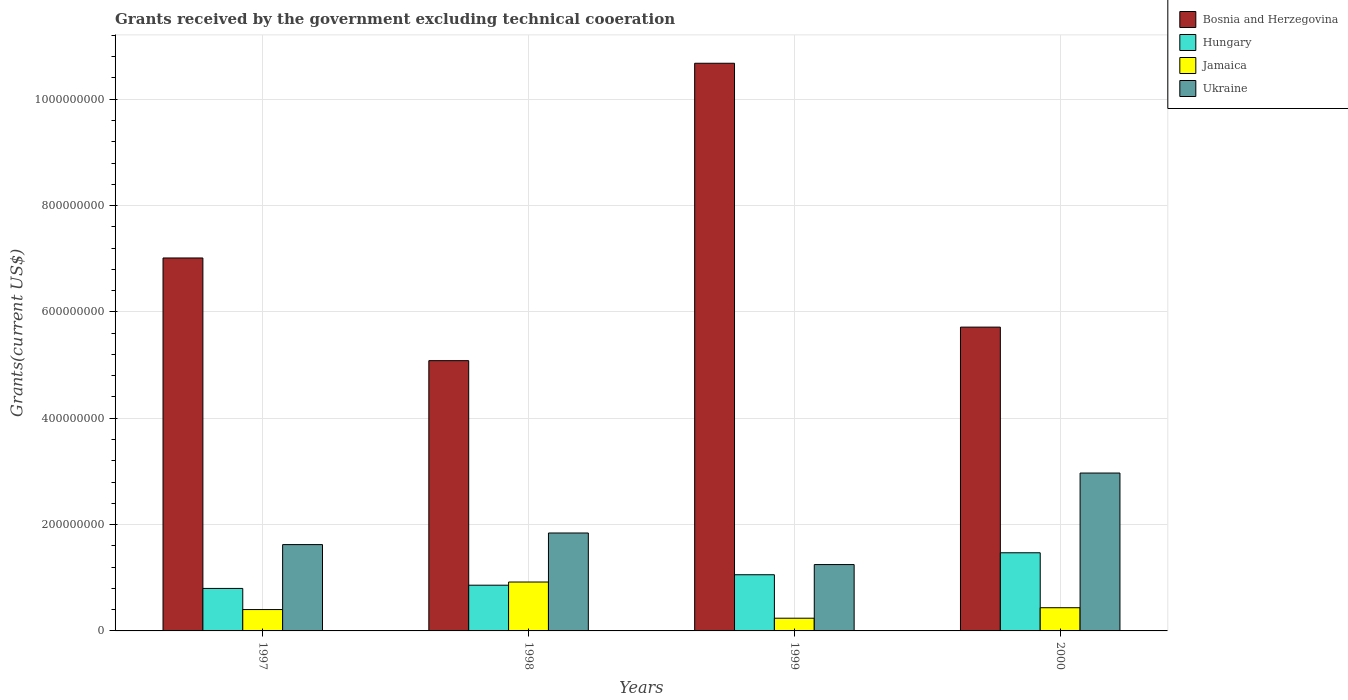How many groups of bars are there?
Your response must be concise. 4. How many bars are there on the 1st tick from the right?
Provide a short and direct response. 4. What is the label of the 2nd group of bars from the left?
Give a very brief answer. 1998. What is the total grants received by the government in Bosnia and Herzegovina in 1999?
Your response must be concise. 1.07e+09. Across all years, what is the maximum total grants received by the government in Jamaica?
Your answer should be very brief. 9.20e+07. Across all years, what is the minimum total grants received by the government in Hungary?
Your answer should be very brief. 7.99e+07. In which year was the total grants received by the government in Bosnia and Herzegovina maximum?
Your answer should be very brief. 1999. What is the total total grants received by the government in Ukraine in the graph?
Your response must be concise. 7.68e+08. What is the difference between the total grants received by the government in Jamaica in 1997 and that in 1999?
Keep it short and to the point. 1.63e+07. What is the difference between the total grants received by the government in Ukraine in 1997 and the total grants received by the government in Jamaica in 1999?
Give a very brief answer. 1.38e+08. What is the average total grants received by the government in Jamaica per year?
Ensure brevity in your answer.  4.99e+07. In the year 1998, what is the difference between the total grants received by the government in Hungary and total grants received by the government in Jamaica?
Your response must be concise. -5.97e+06. In how many years, is the total grants received by the government in Jamaica greater than 360000000 US$?
Offer a very short reply. 0. What is the ratio of the total grants received by the government in Hungary in 1997 to that in 1999?
Make the answer very short. 0.76. Is the total grants received by the government in Bosnia and Herzegovina in 1998 less than that in 1999?
Your answer should be very brief. Yes. What is the difference between the highest and the second highest total grants received by the government in Hungary?
Keep it short and to the point. 4.13e+07. What is the difference between the highest and the lowest total grants received by the government in Ukraine?
Your answer should be very brief. 1.72e+08. Is the sum of the total grants received by the government in Ukraine in 1998 and 1999 greater than the maximum total grants received by the government in Bosnia and Herzegovina across all years?
Ensure brevity in your answer.  No. What does the 2nd bar from the left in 1999 represents?
Give a very brief answer. Hungary. What does the 4th bar from the right in 2000 represents?
Your answer should be compact. Bosnia and Herzegovina. Is it the case that in every year, the sum of the total grants received by the government in Ukraine and total grants received by the government in Jamaica is greater than the total grants received by the government in Bosnia and Herzegovina?
Provide a succinct answer. No. Are all the bars in the graph horizontal?
Ensure brevity in your answer.  No. What is the difference between two consecutive major ticks on the Y-axis?
Provide a short and direct response. 2.00e+08. Where does the legend appear in the graph?
Keep it short and to the point. Top right. How many legend labels are there?
Provide a succinct answer. 4. How are the legend labels stacked?
Your answer should be very brief. Vertical. What is the title of the graph?
Your response must be concise. Grants received by the government excluding technical cooeration. What is the label or title of the Y-axis?
Offer a very short reply. Grants(current US$). What is the Grants(current US$) of Bosnia and Herzegovina in 1997?
Your answer should be compact. 7.01e+08. What is the Grants(current US$) of Hungary in 1997?
Your answer should be compact. 7.99e+07. What is the Grants(current US$) in Jamaica in 1997?
Provide a short and direct response. 4.02e+07. What is the Grants(current US$) of Ukraine in 1997?
Make the answer very short. 1.62e+08. What is the Grants(current US$) in Bosnia and Herzegovina in 1998?
Ensure brevity in your answer.  5.08e+08. What is the Grants(current US$) of Hungary in 1998?
Provide a short and direct response. 8.60e+07. What is the Grants(current US$) of Jamaica in 1998?
Make the answer very short. 9.20e+07. What is the Grants(current US$) in Ukraine in 1998?
Provide a succinct answer. 1.84e+08. What is the Grants(current US$) of Bosnia and Herzegovina in 1999?
Make the answer very short. 1.07e+09. What is the Grants(current US$) of Hungary in 1999?
Your answer should be compact. 1.06e+08. What is the Grants(current US$) in Jamaica in 1999?
Your response must be concise. 2.39e+07. What is the Grants(current US$) of Ukraine in 1999?
Offer a very short reply. 1.25e+08. What is the Grants(current US$) in Bosnia and Herzegovina in 2000?
Provide a succinct answer. 5.71e+08. What is the Grants(current US$) in Hungary in 2000?
Your answer should be compact. 1.47e+08. What is the Grants(current US$) of Jamaica in 2000?
Offer a very short reply. 4.36e+07. What is the Grants(current US$) of Ukraine in 2000?
Provide a succinct answer. 2.97e+08. Across all years, what is the maximum Grants(current US$) of Bosnia and Herzegovina?
Ensure brevity in your answer.  1.07e+09. Across all years, what is the maximum Grants(current US$) of Hungary?
Provide a short and direct response. 1.47e+08. Across all years, what is the maximum Grants(current US$) in Jamaica?
Offer a very short reply. 9.20e+07. Across all years, what is the maximum Grants(current US$) of Ukraine?
Offer a terse response. 2.97e+08. Across all years, what is the minimum Grants(current US$) of Bosnia and Herzegovina?
Your answer should be very brief. 5.08e+08. Across all years, what is the minimum Grants(current US$) of Hungary?
Provide a short and direct response. 7.99e+07. Across all years, what is the minimum Grants(current US$) in Jamaica?
Provide a short and direct response. 2.39e+07. Across all years, what is the minimum Grants(current US$) in Ukraine?
Offer a very short reply. 1.25e+08. What is the total Grants(current US$) of Bosnia and Herzegovina in the graph?
Provide a short and direct response. 2.85e+09. What is the total Grants(current US$) in Hungary in the graph?
Ensure brevity in your answer.  4.19e+08. What is the total Grants(current US$) of Jamaica in the graph?
Your answer should be compact. 2.00e+08. What is the total Grants(current US$) in Ukraine in the graph?
Your response must be concise. 7.68e+08. What is the difference between the Grants(current US$) in Bosnia and Herzegovina in 1997 and that in 1998?
Offer a very short reply. 1.93e+08. What is the difference between the Grants(current US$) in Hungary in 1997 and that in 1998?
Offer a terse response. -6.09e+06. What is the difference between the Grants(current US$) in Jamaica in 1997 and that in 1998?
Make the answer very short. -5.18e+07. What is the difference between the Grants(current US$) of Ukraine in 1997 and that in 1998?
Your answer should be very brief. -2.18e+07. What is the difference between the Grants(current US$) of Bosnia and Herzegovina in 1997 and that in 1999?
Provide a short and direct response. -3.66e+08. What is the difference between the Grants(current US$) of Hungary in 1997 and that in 1999?
Keep it short and to the point. -2.58e+07. What is the difference between the Grants(current US$) of Jamaica in 1997 and that in 1999?
Your answer should be very brief. 1.63e+07. What is the difference between the Grants(current US$) in Ukraine in 1997 and that in 1999?
Provide a succinct answer. 3.76e+07. What is the difference between the Grants(current US$) of Bosnia and Herzegovina in 1997 and that in 2000?
Keep it short and to the point. 1.30e+08. What is the difference between the Grants(current US$) of Hungary in 1997 and that in 2000?
Offer a very short reply. -6.71e+07. What is the difference between the Grants(current US$) of Jamaica in 1997 and that in 2000?
Your answer should be compact. -3.45e+06. What is the difference between the Grants(current US$) in Ukraine in 1997 and that in 2000?
Give a very brief answer. -1.35e+08. What is the difference between the Grants(current US$) of Bosnia and Herzegovina in 1998 and that in 1999?
Ensure brevity in your answer.  -5.59e+08. What is the difference between the Grants(current US$) of Hungary in 1998 and that in 1999?
Keep it short and to the point. -1.97e+07. What is the difference between the Grants(current US$) in Jamaica in 1998 and that in 1999?
Keep it short and to the point. 6.80e+07. What is the difference between the Grants(current US$) of Ukraine in 1998 and that in 1999?
Provide a short and direct response. 5.94e+07. What is the difference between the Grants(current US$) of Bosnia and Herzegovina in 1998 and that in 2000?
Offer a terse response. -6.31e+07. What is the difference between the Grants(current US$) in Hungary in 1998 and that in 2000?
Offer a very short reply. -6.10e+07. What is the difference between the Grants(current US$) of Jamaica in 1998 and that in 2000?
Your response must be concise. 4.83e+07. What is the difference between the Grants(current US$) of Ukraine in 1998 and that in 2000?
Your response must be concise. -1.13e+08. What is the difference between the Grants(current US$) in Bosnia and Herzegovina in 1999 and that in 2000?
Offer a terse response. 4.96e+08. What is the difference between the Grants(current US$) of Hungary in 1999 and that in 2000?
Keep it short and to the point. -4.13e+07. What is the difference between the Grants(current US$) of Jamaica in 1999 and that in 2000?
Provide a succinct answer. -1.97e+07. What is the difference between the Grants(current US$) of Ukraine in 1999 and that in 2000?
Ensure brevity in your answer.  -1.72e+08. What is the difference between the Grants(current US$) of Bosnia and Herzegovina in 1997 and the Grants(current US$) of Hungary in 1998?
Offer a terse response. 6.15e+08. What is the difference between the Grants(current US$) of Bosnia and Herzegovina in 1997 and the Grants(current US$) of Jamaica in 1998?
Keep it short and to the point. 6.09e+08. What is the difference between the Grants(current US$) of Bosnia and Herzegovina in 1997 and the Grants(current US$) of Ukraine in 1998?
Make the answer very short. 5.17e+08. What is the difference between the Grants(current US$) of Hungary in 1997 and the Grants(current US$) of Jamaica in 1998?
Your answer should be very brief. -1.21e+07. What is the difference between the Grants(current US$) of Hungary in 1997 and the Grants(current US$) of Ukraine in 1998?
Keep it short and to the point. -1.04e+08. What is the difference between the Grants(current US$) in Jamaica in 1997 and the Grants(current US$) in Ukraine in 1998?
Offer a very short reply. -1.44e+08. What is the difference between the Grants(current US$) of Bosnia and Herzegovina in 1997 and the Grants(current US$) of Hungary in 1999?
Your answer should be compact. 5.96e+08. What is the difference between the Grants(current US$) of Bosnia and Herzegovina in 1997 and the Grants(current US$) of Jamaica in 1999?
Provide a short and direct response. 6.77e+08. What is the difference between the Grants(current US$) of Bosnia and Herzegovina in 1997 and the Grants(current US$) of Ukraine in 1999?
Ensure brevity in your answer.  5.77e+08. What is the difference between the Grants(current US$) of Hungary in 1997 and the Grants(current US$) of Jamaica in 1999?
Keep it short and to the point. 5.60e+07. What is the difference between the Grants(current US$) of Hungary in 1997 and the Grants(current US$) of Ukraine in 1999?
Provide a succinct answer. -4.49e+07. What is the difference between the Grants(current US$) in Jamaica in 1997 and the Grants(current US$) in Ukraine in 1999?
Give a very brief answer. -8.46e+07. What is the difference between the Grants(current US$) of Bosnia and Herzegovina in 1997 and the Grants(current US$) of Hungary in 2000?
Keep it short and to the point. 5.54e+08. What is the difference between the Grants(current US$) in Bosnia and Herzegovina in 1997 and the Grants(current US$) in Jamaica in 2000?
Your response must be concise. 6.58e+08. What is the difference between the Grants(current US$) in Bosnia and Herzegovina in 1997 and the Grants(current US$) in Ukraine in 2000?
Provide a succinct answer. 4.04e+08. What is the difference between the Grants(current US$) of Hungary in 1997 and the Grants(current US$) of Jamaica in 2000?
Your answer should be very brief. 3.63e+07. What is the difference between the Grants(current US$) in Hungary in 1997 and the Grants(current US$) in Ukraine in 2000?
Keep it short and to the point. -2.17e+08. What is the difference between the Grants(current US$) in Jamaica in 1997 and the Grants(current US$) in Ukraine in 2000?
Your answer should be compact. -2.57e+08. What is the difference between the Grants(current US$) of Bosnia and Herzegovina in 1998 and the Grants(current US$) of Hungary in 1999?
Provide a succinct answer. 4.03e+08. What is the difference between the Grants(current US$) in Bosnia and Herzegovina in 1998 and the Grants(current US$) in Jamaica in 1999?
Your response must be concise. 4.84e+08. What is the difference between the Grants(current US$) in Bosnia and Herzegovina in 1998 and the Grants(current US$) in Ukraine in 1999?
Make the answer very short. 3.84e+08. What is the difference between the Grants(current US$) of Hungary in 1998 and the Grants(current US$) of Jamaica in 1999?
Keep it short and to the point. 6.21e+07. What is the difference between the Grants(current US$) of Hungary in 1998 and the Grants(current US$) of Ukraine in 1999?
Provide a short and direct response. -3.88e+07. What is the difference between the Grants(current US$) of Jamaica in 1998 and the Grants(current US$) of Ukraine in 1999?
Your answer should be very brief. -3.28e+07. What is the difference between the Grants(current US$) of Bosnia and Herzegovina in 1998 and the Grants(current US$) of Hungary in 2000?
Offer a terse response. 3.61e+08. What is the difference between the Grants(current US$) of Bosnia and Herzegovina in 1998 and the Grants(current US$) of Jamaica in 2000?
Offer a very short reply. 4.65e+08. What is the difference between the Grants(current US$) in Bosnia and Herzegovina in 1998 and the Grants(current US$) in Ukraine in 2000?
Your answer should be compact. 2.11e+08. What is the difference between the Grants(current US$) of Hungary in 1998 and the Grants(current US$) of Jamaica in 2000?
Your answer should be compact. 4.24e+07. What is the difference between the Grants(current US$) of Hungary in 1998 and the Grants(current US$) of Ukraine in 2000?
Give a very brief answer. -2.11e+08. What is the difference between the Grants(current US$) of Jamaica in 1998 and the Grants(current US$) of Ukraine in 2000?
Offer a terse response. -2.05e+08. What is the difference between the Grants(current US$) of Bosnia and Herzegovina in 1999 and the Grants(current US$) of Hungary in 2000?
Your answer should be compact. 9.21e+08. What is the difference between the Grants(current US$) in Bosnia and Herzegovina in 1999 and the Grants(current US$) in Jamaica in 2000?
Offer a terse response. 1.02e+09. What is the difference between the Grants(current US$) in Bosnia and Herzegovina in 1999 and the Grants(current US$) in Ukraine in 2000?
Your answer should be compact. 7.71e+08. What is the difference between the Grants(current US$) in Hungary in 1999 and the Grants(current US$) in Jamaica in 2000?
Provide a succinct answer. 6.20e+07. What is the difference between the Grants(current US$) in Hungary in 1999 and the Grants(current US$) in Ukraine in 2000?
Keep it short and to the point. -1.91e+08. What is the difference between the Grants(current US$) in Jamaica in 1999 and the Grants(current US$) in Ukraine in 2000?
Provide a short and direct response. -2.73e+08. What is the average Grants(current US$) in Bosnia and Herzegovina per year?
Offer a terse response. 7.12e+08. What is the average Grants(current US$) in Hungary per year?
Keep it short and to the point. 1.05e+08. What is the average Grants(current US$) of Jamaica per year?
Your response must be concise. 4.99e+07. What is the average Grants(current US$) of Ukraine per year?
Offer a terse response. 1.92e+08. In the year 1997, what is the difference between the Grants(current US$) of Bosnia and Herzegovina and Grants(current US$) of Hungary?
Keep it short and to the point. 6.22e+08. In the year 1997, what is the difference between the Grants(current US$) of Bosnia and Herzegovina and Grants(current US$) of Jamaica?
Make the answer very short. 6.61e+08. In the year 1997, what is the difference between the Grants(current US$) in Bosnia and Herzegovina and Grants(current US$) in Ukraine?
Make the answer very short. 5.39e+08. In the year 1997, what is the difference between the Grants(current US$) in Hungary and Grants(current US$) in Jamaica?
Make the answer very short. 3.97e+07. In the year 1997, what is the difference between the Grants(current US$) of Hungary and Grants(current US$) of Ukraine?
Make the answer very short. -8.24e+07. In the year 1997, what is the difference between the Grants(current US$) of Jamaica and Grants(current US$) of Ukraine?
Offer a terse response. -1.22e+08. In the year 1998, what is the difference between the Grants(current US$) of Bosnia and Herzegovina and Grants(current US$) of Hungary?
Provide a short and direct response. 4.22e+08. In the year 1998, what is the difference between the Grants(current US$) of Bosnia and Herzegovina and Grants(current US$) of Jamaica?
Your response must be concise. 4.16e+08. In the year 1998, what is the difference between the Grants(current US$) in Bosnia and Herzegovina and Grants(current US$) in Ukraine?
Provide a short and direct response. 3.24e+08. In the year 1998, what is the difference between the Grants(current US$) in Hungary and Grants(current US$) in Jamaica?
Keep it short and to the point. -5.97e+06. In the year 1998, what is the difference between the Grants(current US$) of Hungary and Grants(current US$) of Ukraine?
Make the answer very short. -9.82e+07. In the year 1998, what is the difference between the Grants(current US$) in Jamaica and Grants(current US$) in Ukraine?
Offer a very short reply. -9.22e+07. In the year 1999, what is the difference between the Grants(current US$) in Bosnia and Herzegovina and Grants(current US$) in Hungary?
Provide a short and direct response. 9.62e+08. In the year 1999, what is the difference between the Grants(current US$) in Bosnia and Herzegovina and Grants(current US$) in Jamaica?
Make the answer very short. 1.04e+09. In the year 1999, what is the difference between the Grants(current US$) of Bosnia and Herzegovina and Grants(current US$) of Ukraine?
Your answer should be compact. 9.43e+08. In the year 1999, what is the difference between the Grants(current US$) of Hungary and Grants(current US$) of Jamaica?
Your answer should be compact. 8.18e+07. In the year 1999, what is the difference between the Grants(current US$) in Hungary and Grants(current US$) in Ukraine?
Offer a very short reply. -1.91e+07. In the year 1999, what is the difference between the Grants(current US$) of Jamaica and Grants(current US$) of Ukraine?
Offer a terse response. -1.01e+08. In the year 2000, what is the difference between the Grants(current US$) in Bosnia and Herzegovina and Grants(current US$) in Hungary?
Your answer should be compact. 4.24e+08. In the year 2000, what is the difference between the Grants(current US$) in Bosnia and Herzegovina and Grants(current US$) in Jamaica?
Provide a succinct answer. 5.28e+08. In the year 2000, what is the difference between the Grants(current US$) of Bosnia and Herzegovina and Grants(current US$) of Ukraine?
Provide a succinct answer. 2.74e+08. In the year 2000, what is the difference between the Grants(current US$) of Hungary and Grants(current US$) of Jamaica?
Give a very brief answer. 1.03e+08. In the year 2000, what is the difference between the Grants(current US$) of Hungary and Grants(current US$) of Ukraine?
Ensure brevity in your answer.  -1.50e+08. In the year 2000, what is the difference between the Grants(current US$) of Jamaica and Grants(current US$) of Ukraine?
Keep it short and to the point. -2.53e+08. What is the ratio of the Grants(current US$) of Bosnia and Herzegovina in 1997 to that in 1998?
Offer a terse response. 1.38. What is the ratio of the Grants(current US$) of Hungary in 1997 to that in 1998?
Your response must be concise. 0.93. What is the ratio of the Grants(current US$) in Jamaica in 1997 to that in 1998?
Offer a very short reply. 0.44. What is the ratio of the Grants(current US$) in Ukraine in 1997 to that in 1998?
Provide a succinct answer. 0.88. What is the ratio of the Grants(current US$) of Bosnia and Herzegovina in 1997 to that in 1999?
Keep it short and to the point. 0.66. What is the ratio of the Grants(current US$) in Hungary in 1997 to that in 1999?
Ensure brevity in your answer.  0.76. What is the ratio of the Grants(current US$) of Jamaica in 1997 to that in 1999?
Give a very brief answer. 1.68. What is the ratio of the Grants(current US$) of Ukraine in 1997 to that in 1999?
Your answer should be compact. 1.3. What is the ratio of the Grants(current US$) in Bosnia and Herzegovina in 1997 to that in 2000?
Your answer should be very brief. 1.23. What is the ratio of the Grants(current US$) in Hungary in 1997 to that in 2000?
Your answer should be compact. 0.54. What is the ratio of the Grants(current US$) in Jamaica in 1997 to that in 2000?
Keep it short and to the point. 0.92. What is the ratio of the Grants(current US$) in Ukraine in 1997 to that in 2000?
Ensure brevity in your answer.  0.55. What is the ratio of the Grants(current US$) in Bosnia and Herzegovina in 1998 to that in 1999?
Your response must be concise. 0.48. What is the ratio of the Grants(current US$) of Hungary in 1998 to that in 1999?
Keep it short and to the point. 0.81. What is the ratio of the Grants(current US$) of Jamaica in 1998 to that in 1999?
Provide a short and direct response. 3.85. What is the ratio of the Grants(current US$) of Ukraine in 1998 to that in 1999?
Give a very brief answer. 1.48. What is the ratio of the Grants(current US$) in Bosnia and Herzegovina in 1998 to that in 2000?
Keep it short and to the point. 0.89. What is the ratio of the Grants(current US$) in Hungary in 1998 to that in 2000?
Offer a very short reply. 0.58. What is the ratio of the Grants(current US$) of Jamaica in 1998 to that in 2000?
Provide a succinct answer. 2.11. What is the ratio of the Grants(current US$) in Ukraine in 1998 to that in 2000?
Your response must be concise. 0.62. What is the ratio of the Grants(current US$) in Bosnia and Herzegovina in 1999 to that in 2000?
Provide a succinct answer. 1.87. What is the ratio of the Grants(current US$) of Hungary in 1999 to that in 2000?
Your response must be concise. 0.72. What is the ratio of the Grants(current US$) in Jamaica in 1999 to that in 2000?
Your answer should be compact. 0.55. What is the ratio of the Grants(current US$) of Ukraine in 1999 to that in 2000?
Provide a succinct answer. 0.42. What is the difference between the highest and the second highest Grants(current US$) of Bosnia and Herzegovina?
Keep it short and to the point. 3.66e+08. What is the difference between the highest and the second highest Grants(current US$) in Hungary?
Provide a short and direct response. 4.13e+07. What is the difference between the highest and the second highest Grants(current US$) of Jamaica?
Your answer should be compact. 4.83e+07. What is the difference between the highest and the second highest Grants(current US$) of Ukraine?
Keep it short and to the point. 1.13e+08. What is the difference between the highest and the lowest Grants(current US$) of Bosnia and Herzegovina?
Your response must be concise. 5.59e+08. What is the difference between the highest and the lowest Grants(current US$) of Hungary?
Offer a very short reply. 6.71e+07. What is the difference between the highest and the lowest Grants(current US$) of Jamaica?
Your answer should be compact. 6.80e+07. What is the difference between the highest and the lowest Grants(current US$) of Ukraine?
Offer a very short reply. 1.72e+08. 